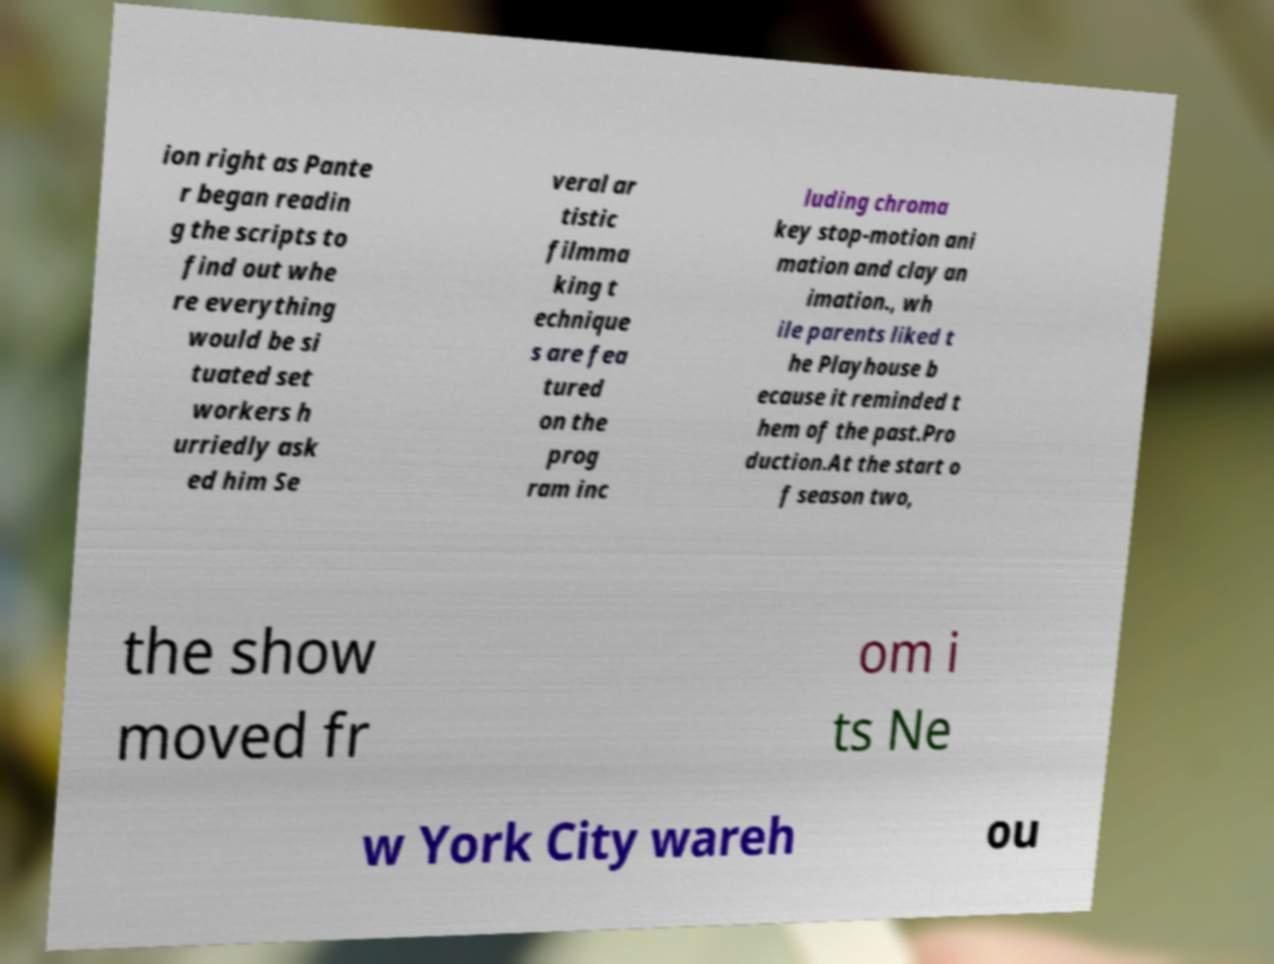Can you accurately transcribe the text from the provided image for me? ion right as Pante r began readin g the scripts to find out whe re everything would be si tuated set workers h urriedly ask ed him Se veral ar tistic filmma king t echnique s are fea tured on the prog ram inc luding chroma key stop-motion ani mation and clay an imation., wh ile parents liked t he Playhouse b ecause it reminded t hem of the past.Pro duction.At the start o f season two, the show moved fr om i ts Ne w York City wareh ou 